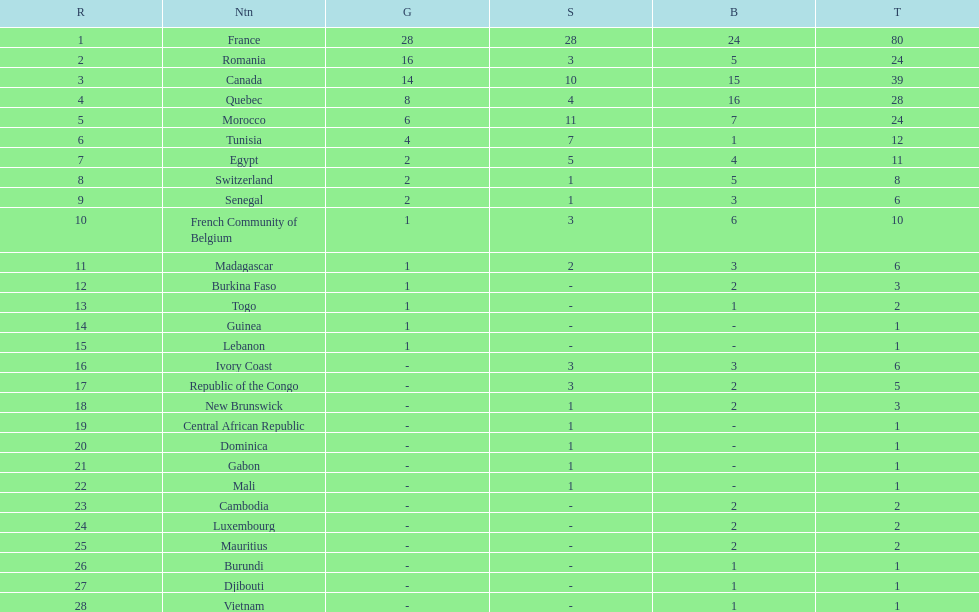How many bronze medals does togo have? 1. 